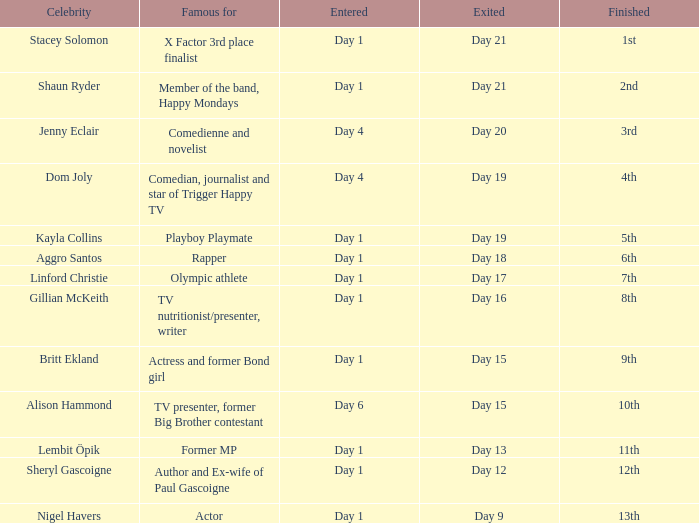What position did the celebrity finish that entered on day 1 and exited on day 19? 5th. 